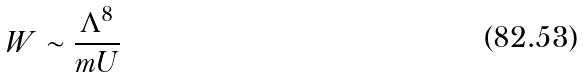<formula> <loc_0><loc_0><loc_500><loc_500>W \sim \frac { \Lambda ^ { 8 } } { m U }</formula> 